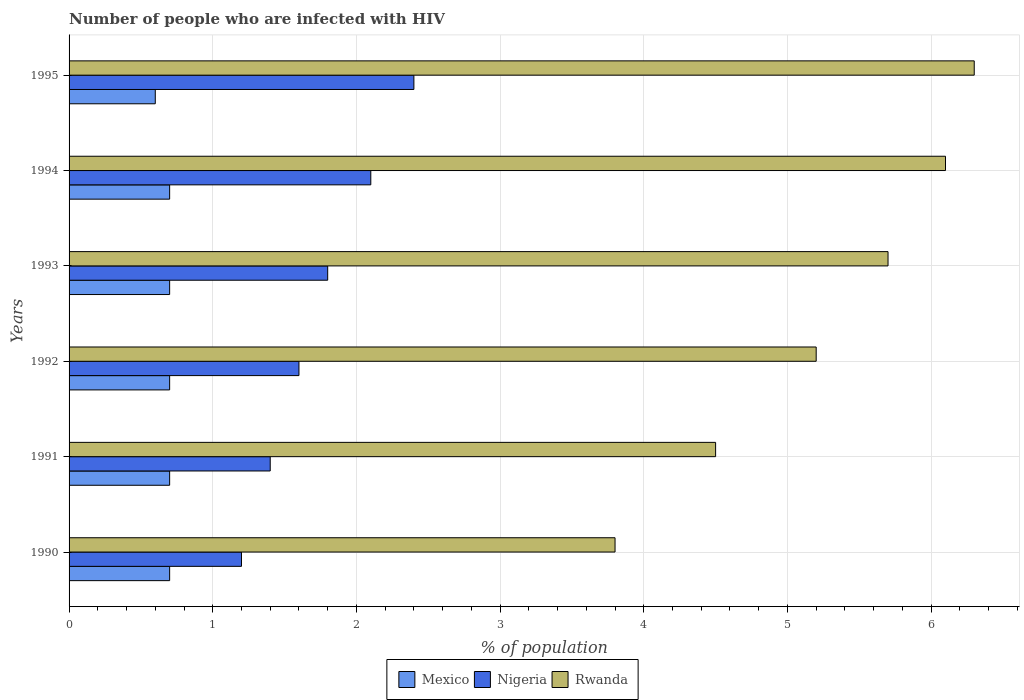How many different coloured bars are there?
Your answer should be very brief. 3. How many groups of bars are there?
Your answer should be compact. 6. Are the number of bars per tick equal to the number of legend labels?
Give a very brief answer. Yes. How many bars are there on the 5th tick from the top?
Your response must be concise. 3. How many bars are there on the 5th tick from the bottom?
Your answer should be compact. 3. What is the percentage of HIV infected population in in Rwanda in 1995?
Provide a short and direct response. 6.3. Across all years, what is the maximum percentage of HIV infected population in in Rwanda?
Provide a succinct answer. 6.3. Across all years, what is the minimum percentage of HIV infected population in in Mexico?
Give a very brief answer. 0.6. In which year was the percentage of HIV infected population in in Nigeria maximum?
Ensure brevity in your answer.  1995. In which year was the percentage of HIV infected population in in Mexico minimum?
Make the answer very short. 1995. What is the total percentage of HIV infected population in in Nigeria in the graph?
Keep it short and to the point. 10.5. What is the difference between the percentage of HIV infected population in in Rwanda in 1990 and the percentage of HIV infected population in in Mexico in 1991?
Keep it short and to the point. 3.1. What is the average percentage of HIV infected population in in Rwanda per year?
Give a very brief answer. 5.27. What is the ratio of the percentage of HIV infected population in in Nigeria in 1992 to that in 1994?
Your answer should be compact. 0.76. Is the percentage of HIV infected population in in Nigeria in 1992 less than that in 1993?
Your answer should be very brief. Yes. What is the difference between the highest and the second highest percentage of HIV infected population in in Rwanda?
Your response must be concise. 0.2. In how many years, is the percentage of HIV infected population in in Rwanda greater than the average percentage of HIV infected population in in Rwanda taken over all years?
Provide a succinct answer. 3. What does the 2nd bar from the bottom in 1992 represents?
Your answer should be compact. Nigeria. Is it the case that in every year, the sum of the percentage of HIV infected population in in Rwanda and percentage of HIV infected population in in Mexico is greater than the percentage of HIV infected population in in Nigeria?
Offer a terse response. Yes. Are all the bars in the graph horizontal?
Your response must be concise. Yes. Are the values on the major ticks of X-axis written in scientific E-notation?
Your answer should be very brief. No. Does the graph contain any zero values?
Make the answer very short. No. How many legend labels are there?
Offer a terse response. 3. How are the legend labels stacked?
Make the answer very short. Horizontal. What is the title of the graph?
Make the answer very short. Number of people who are infected with HIV. Does "Singapore" appear as one of the legend labels in the graph?
Keep it short and to the point. No. What is the label or title of the X-axis?
Your answer should be compact. % of population. What is the % of population in Mexico in 1990?
Keep it short and to the point. 0.7. What is the % of population in Nigeria in 1990?
Offer a terse response. 1.2. What is the % of population in Rwanda in 1990?
Your response must be concise. 3.8. What is the % of population in Mexico in 1991?
Your answer should be compact. 0.7. What is the % of population in Rwanda in 1991?
Provide a short and direct response. 4.5. What is the % of population of Mexico in 1992?
Ensure brevity in your answer.  0.7. What is the % of population in Rwanda in 1994?
Make the answer very short. 6.1. Across all years, what is the maximum % of population of Nigeria?
Give a very brief answer. 2.4. Across all years, what is the maximum % of population of Rwanda?
Offer a very short reply. 6.3. Across all years, what is the minimum % of population of Mexico?
Your response must be concise. 0.6. Across all years, what is the minimum % of population in Nigeria?
Offer a terse response. 1.2. What is the total % of population in Nigeria in the graph?
Give a very brief answer. 10.5. What is the total % of population of Rwanda in the graph?
Make the answer very short. 31.6. What is the difference between the % of population of Mexico in 1990 and that in 1991?
Make the answer very short. 0. What is the difference between the % of population in Nigeria in 1990 and that in 1991?
Offer a very short reply. -0.2. What is the difference between the % of population in Rwanda in 1990 and that in 1991?
Your answer should be compact. -0.7. What is the difference between the % of population in Mexico in 1990 and that in 1992?
Your answer should be very brief. 0. What is the difference between the % of population in Rwanda in 1990 and that in 1993?
Provide a succinct answer. -1.9. What is the difference between the % of population of Mexico in 1990 and that in 1994?
Give a very brief answer. 0. What is the difference between the % of population in Rwanda in 1990 and that in 1994?
Give a very brief answer. -2.3. What is the difference between the % of population in Mexico in 1990 and that in 1995?
Provide a succinct answer. 0.1. What is the difference between the % of population of Nigeria in 1990 and that in 1995?
Your response must be concise. -1.2. What is the difference between the % of population of Rwanda in 1990 and that in 1995?
Offer a very short reply. -2.5. What is the difference between the % of population in Mexico in 1991 and that in 1992?
Ensure brevity in your answer.  0. What is the difference between the % of population of Nigeria in 1991 and that in 1992?
Provide a succinct answer. -0.2. What is the difference between the % of population in Mexico in 1991 and that in 1993?
Offer a very short reply. 0. What is the difference between the % of population of Nigeria in 1991 and that in 1993?
Offer a very short reply. -0.4. What is the difference between the % of population in Nigeria in 1991 and that in 1994?
Offer a very short reply. -0.7. What is the difference between the % of population in Rwanda in 1991 and that in 1995?
Keep it short and to the point. -1.8. What is the difference between the % of population of Mexico in 1992 and that in 1993?
Keep it short and to the point. 0. What is the difference between the % of population of Mexico in 1992 and that in 1994?
Your answer should be very brief. 0. What is the difference between the % of population of Rwanda in 1992 and that in 1994?
Make the answer very short. -0.9. What is the difference between the % of population in Mexico in 1992 and that in 1995?
Provide a succinct answer. 0.1. What is the difference between the % of population in Rwanda in 1992 and that in 1995?
Provide a short and direct response. -1.1. What is the difference between the % of population of Mexico in 1993 and that in 1995?
Provide a succinct answer. 0.1. What is the difference between the % of population of Nigeria in 1993 and that in 1995?
Provide a succinct answer. -0.6. What is the difference between the % of population in Nigeria in 1994 and that in 1995?
Provide a short and direct response. -0.3. What is the difference between the % of population in Rwanda in 1994 and that in 1995?
Make the answer very short. -0.2. What is the difference between the % of population of Mexico in 1990 and the % of population of Rwanda in 1991?
Give a very brief answer. -3.8. What is the difference between the % of population in Nigeria in 1990 and the % of population in Rwanda in 1991?
Keep it short and to the point. -3.3. What is the difference between the % of population of Nigeria in 1990 and the % of population of Rwanda in 1993?
Your response must be concise. -4.5. What is the difference between the % of population in Mexico in 1991 and the % of population in Nigeria in 1993?
Make the answer very short. -1.1. What is the difference between the % of population of Mexico in 1991 and the % of population of Rwanda in 1993?
Provide a succinct answer. -5. What is the difference between the % of population of Nigeria in 1991 and the % of population of Rwanda in 1993?
Your response must be concise. -4.3. What is the difference between the % of population in Mexico in 1991 and the % of population in Nigeria in 1994?
Offer a terse response. -1.4. What is the difference between the % of population of Mexico in 1991 and the % of population of Rwanda in 1994?
Offer a very short reply. -5.4. What is the difference between the % of population in Nigeria in 1991 and the % of population in Rwanda in 1994?
Your response must be concise. -4.7. What is the difference between the % of population in Mexico in 1991 and the % of population in Rwanda in 1995?
Provide a short and direct response. -5.6. What is the difference between the % of population in Nigeria in 1991 and the % of population in Rwanda in 1995?
Your answer should be very brief. -4.9. What is the difference between the % of population of Mexico in 1992 and the % of population of Nigeria in 1993?
Offer a very short reply. -1.1. What is the difference between the % of population of Mexico in 1992 and the % of population of Rwanda in 1993?
Keep it short and to the point. -5. What is the difference between the % of population in Nigeria in 1992 and the % of population in Rwanda in 1994?
Make the answer very short. -4.5. What is the difference between the % of population in Nigeria in 1993 and the % of population in Rwanda in 1994?
Keep it short and to the point. -4.3. What is the difference between the % of population of Mexico in 1993 and the % of population of Rwanda in 1995?
Make the answer very short. -5.6. What is the difference between the % of population in Mexico in 1994 and the % of population in Rwanda in 1995?
Give a very brief answer. -5.6. What is the difference between the % of population in Nigeria in 1994 and the % of population in Rwanda in 1995?
Give a very brief answer. -4.2. What is the average % of population of Mexico per year?
Give a very brief answer. 0.68. What is the average % of population in Rwanda per year?
Ensure brevity in your answer.  5.27. In the year 1990, what is the difference between the % of population of Mexico and % of population of Nigeria?
Your answer should be compact. -0.5. In the year 1990, what is the difference between the % of population of Mexico and % of population of Rwanda?
Offer a terse response. -3.1. In the year 1990, what is the difference between the % of population in Nigeria and % of population in Rwanda?
Keep it short and to the point. -2.6. In the year 1991, what is the difference between the % of population in Mexico and % of population in Rwanda?
Your response must be concise. -3.8. In the year 1992, what is the difference between the % of population of Nigeria and % of population of Rwanda?
Your answer should be compact. -3.6. In the year 1993, what is the difference between the % of population of Mexico and % of population of Nigeria?
Keep it short and to the point. -1.1. In the year 1993, what is the difference between the % of population of Mexico and % of population of Rwanda?
Keep it short and to the point. -5. In the year 1993, what is the difference between the % of population in Nigeria and % of population in Rwanda?
Make the answer very short. -3.9. In the year 1994, what is the difference between the % of population in Nigeria and % of population in Rwanda?
Ensure brevity in your answer.  -4. In the year 1995, what is the difference between the % of population in Mexico and % of population in Nigeria?
Ensure brevity in your answer.  -1.8. In the year 1995, what is the difference between the % of population in Mexico and % of population in Rwanda?
Make the answer very short. -5.7. In the year 1995, what is the difference between the % of population of Nigeria and % of population of Rwanda?
Your answer should be compact. -3.9. What is the ratio of the % of population of Mexico in 1990 to that in 1991?
Your response must be concise. 1. What is the ratio of the % of population of Rwanda in 1990 to that in 1991?
Provide a short and direct response. 0.84. What is the ratio of the % of population of Mexico in 1990 to that in 1992?
Offer a very short reply. 1. What is the ratio of the % of population of Nigeria in 1990 to that in 1992?
Provide a short and direct response. 0.75. What is the ratio of the % of population of Rwanda in 1990 to that in 1992?
Give a very brief answer. 0.73. What is the ratio of the % of population in Mexico in 1990 to that in 1993?
Make the answer very short. 1. What is the ratio of the % of population in Nigeria in 1990 to that in 1993?
Provide a short and direct response. 0.67. What is the ratio of the % of population in Nigeria in 1990 to that in 1994?
Provide a succinct answer. 0.57. What is the ratio of the % of population in Rwanda in 1990 to that in 1994?
Give a very brief answer. 0.62. What is the ratio of the % of population in Mexico in 1990 to that in 1995?
Your answer should be compact. 1.17. What is the ratio of the % of population in Nigeria in 1990 to that in 1995?
Your answer should be very brief. 0.5. What is the ratio of the % of population of Rwanda in 1990 to that in 1995?
Make the answer very short. 0.6. What is the ratio of the % of population of Mexico in 1991 to that in 1992?
Offer a terse response. 1. What is the ratio of the % of population of Nigeria in 1991 to that in 1992?
Provide a succinct answer. 0.88. What is the ratio of the % of population in Rwanda in 1991 to that in 1992?
Offer a terse response. 0.87. What is the ratio of the % of population in Mexico in 1991 to that in 1993?
Provide a short and direct response. 1. What is the ratio of the % of population in Rwanda in 1991 to that in 1993?
Your answer should be compact. 0.79. What is the ratio of the % of population of Rwanda in 1991 to that in 1994?
Provide a short and direct response. 0.74. What is the ratio of the % of population in Mexico in 1991 to that in 1995?
Your response must be concise. 1.17. What is the ratio of the % of population in Nigeria in 1991 to that in 1995?
Ensure brevity in your answer.  0.58. What is the ratio of the % of population in Rwanda in 1991 to that in 1995?
Provide a short and direct response. 0.71. What is the ratio of the % of population of Mexico in 1992 to that in 1993?
Your answer should be compact. 1. What is the ratio of the % of population in Nigeria in 1992 to that in 1993?
Your response must be concise. 0.89. What is the ratio of the % of population of Rwanda in 1992 to that in 1993?
Your answer should be compact. 0.91. What is the ratio of the % of population of Nigeria in 1992 to that in 1994?
Make the answer very short. 0.76. What is the ratio of the % of population of Rwanda in 1992 to that in 1994?
Your answer should be compact. 0.85. What is the ratio of the % of population in Mexico in 1992 to that in 1995?
Give a very brief answer. 1.17. What is the ratio of the % of population of Nigeria in 1992 to that in 1995?
Your response must be concise. 0.67. What is the ratio of the % of population in Rwanda in 1992 to that in 1995?
Provide a succinct answer. 0.83. What is the ratio of the % of population of Mexico in 1993 to that in 1994?
Your answer should be very brief. 1. What is the ratio of the % of population in Nigeria in 1993 to that in 1994?
Your answer should be very brief. 0.86. What is the ratio of the % of population of Rwanda in 1993 to that in 1994?
Keep it short and to the point. 0.93. What is the ratio of the % of population of Mexico in 1993 to that in 1995?
Offer a terse response. 1.17. What is the ratio of the % of population in Rwanda in 1993 to that in 1995?
Provide a succinct answer. 0.9. What is the ratio of the % of population of Rwanda in 1994 to that in 1995?
Provide a succinct answer. 0.97. What is the difference between the highest and the second highest % of population in Nigeria?
Offer a terse response. 0.3. What is the difference between the highest and the second highest % of population of Rwanda?
Provide a short and direct response. 0.2. What is the difference between the highest and the lowest % of population in Mexico?
Provide a succinct answer. 0.1. What is the difference between the highest and the lowest % of population of Nigeria?
Your answer should be compact. 1.2. 